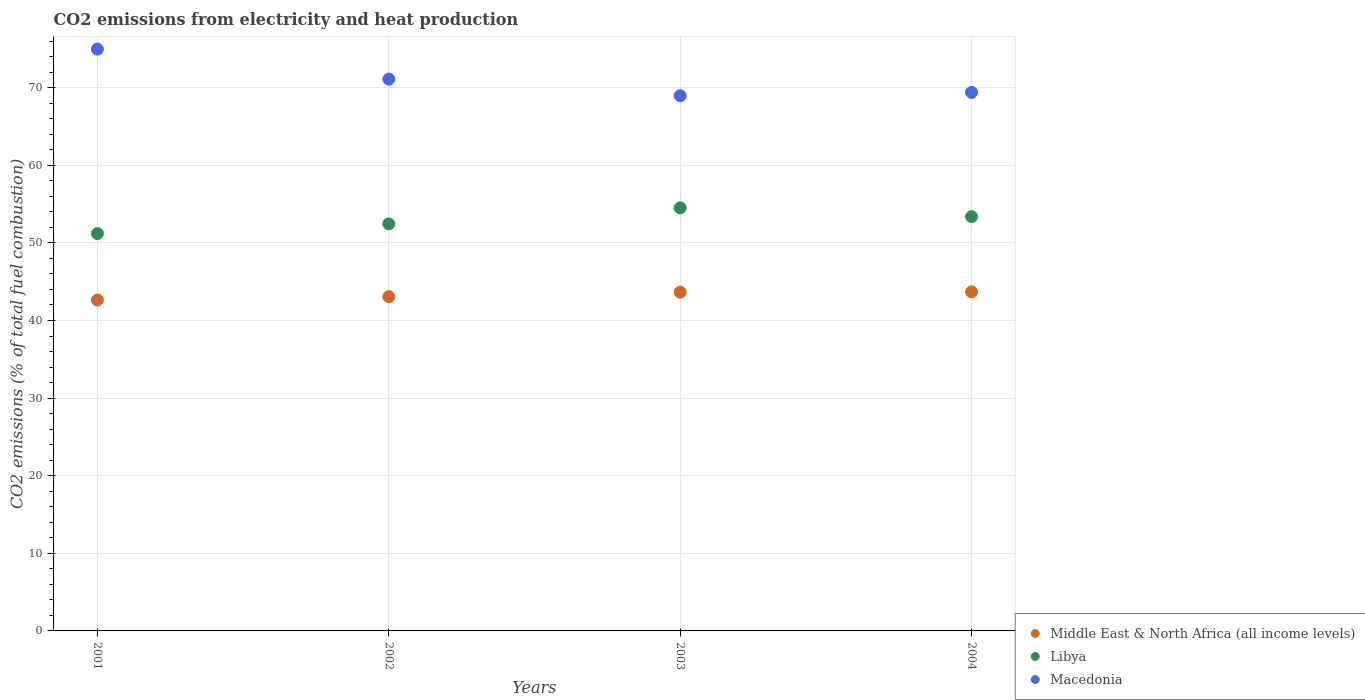How many different coloured dotlines are there?
Your response must be concise. 3. What is the amount of CO2 emitted in Macedonia in 2002?
Provide a succinct answer. 71.11. Across all years, what is the maximum amount of CO2 emitted in Libya?
Keep it short and to the point. 54.52. Across all years, what is the minimum amount of CO2 emitted in Libya?
Provide a short and direct response. 51.21. In which year was the amount of CO2 emitted in Middle East & North Africa (all income levels) minimum?
Provide a succinct answer. 2001. What is the total amount of CO2 emitted in Macedonia in the graph?
Keep it short and to the point. 284.44. What is the difference between the amount of CO2 emitted in Libya in 2003 and that in 2004?
Provide a short and direct response. 1.13. What is the difference between the amount of CO2 emitted in Middle East & North Africa (all income levels) in 2002 and the amount of CO2 emitted in Libya in 2003?
Your answer should be compact. -11.44. What is the average amount of CO2 emitted in Middle East & North Africa (all income levels) per year?
Give a very brief answer. 43.26. In the year 2002, what is the difference between the amount of CO2 emitted in Macedonia and amount of CO2 emitted in Libya?
Give a very brief answer. 18.66. In how many years, is the amount of CO2 emitted in Libya greater than 20 %?
Provide a succinct answer. 4. What is the ratio of the amount of CO2 emitted in Macedonia in 2002 to that in 2004?
Keep it short and to the point. 1.02. Is the amount of CO2 emitted in Macedonia in 2001 less than that in 2003?
Offer a very short reply. No. Is the difference between the amount of CO2 emitted in Macedonia in 2001 and 2003 greater than the difference between the amount of CO2 emitted in Libya in 2001 and 2003?
Give a very brief answer. Yes. What is the difference between the highest and the second highest amount of CO2 emitted in Libya?
Give a very brief answer. 1.13. What is the difference between the highest and the lowest amount of CO2 emitted in Libya?
Make the answer very short. 3.31. In how many years, is the amount of CO2 emitted in Libya greater than the average amount of CO2 emitted in Libya taken over all years?
Your answer should be very brief. 2. Does the amount of CO2 emitted in Libya monotonically increase over the years?
Provide a succinct answer. No. Is the amount of CO2 emitted in Libya strictly greater than the amount of CO2 emitted in Middle East & North Africa (all income levels) over the years?
Your answer should be very brief. Yes. Is the amount of CO2 emitted in Libya strictly less than the amount of CO2 emitted in Macedonia over the years?
Your answer should be compact. Yes. How many years are there in the graph?
Provide a short and direct response. 4. Does the graph contain any zero values?
Your response must be concise. No. How many legend labels are there?
Your answer should be very brief. 3. What is the title of the graph?
Offer a very short reply. CO2 emissions from electricity and heat production. Does "Virgin Islands" appear as one of the legend labels in the graph?
Your answer should be very brief. No. What is the label or title of the Y-axis?
Provide a short and direct response. CO2 emissions (% of total fuel combustion). What is the CO2 emissions (% of total fuel combustion) of Middle East & North Africa (all income levels) in 2001?
Keep it short and to the point. 42.64. What is the CO2 emissions (% of total fuel combustion) of Libya in 2001?
Your answer should be compact. 51.21. What is the CO2 emissions (% of total fuel combustion) in Macedonia in 2001?
Provide a short and direct response. 74.97. What is the CO2 emissions (% of total fuel combustion) in Middle East & North Africa (all income levels) in 2002?
Provide a short and direct response. 43.07. What is the CO2 emissions (% of total fuel combustion) in Libya in 2002?
Make the answer very short. 52.45. What is the CO2 emissions (% of total fuel combustion) of Macedonia in 2002?
Ensure brevity in your answer.  71.11. What is the CO2 emissions (% of total fuel combustion) of Middle East & North Africa (all income levels) in 2003?
Your answer should be compact. 43.65. What is the CO2 emissions (% of total fuel combustion) of Libya in 2003?
Your answer should be compact. 54.52. What is the CO2 emissions (% of total fuel combustion) of Macedonia in 2003?
Keep it short and to the point. 68.97. What is the CO2 emissions (% of total fuel combustion) in Middle East & North Africa (all income levels) in 2004?
Offer a terse response. 43.69. What is the CO2 emissions (% of total fuel combustion) in Libya in 2004?
Give a very brief answer. 53.38. What is the CO2 emissions (% of total fuel combustion) of Macedonia in 2004?
Make the answer very short. 69.4. Across all years, what is the maximum CO2 emissions (% of total fuel combustion) of Middle East & North Africa (all income levels)?
Your answer should be very brief. 43.69. Across all years, what is the maximum CO2 emissions (% of total fuel combustion) of Libya?
Provide a succinct answer. 54.52. Across all years, what is the maximum CO2 emissions (% of total fuel combustion) in Macedonia?
Offer a terse response. 74.97. Across all years, what is the minimum CO2 emissions (% of total fuel combustion) in Middle East & North Africa (all income levels)?
Your answer should be very brief. 42.64. Across all years, what is the minimum CO2 emissions (% of total fuel combustion) in Libya?
Make the answer very short. 51.21. Across all years, what is the minimum CO2 emissions (% of total fuel combustion) of Macedonia?
Offer a very short reply. 68.97. What is the total CO2 emissions (% of total fuel combustion) in Middle East & North Africa (all income levels) in the graph?
Provide a succinct answer. 173.05. What is the total CO2 emissions (% of total fuel combustion) of Libya in the graph?
Your response must be concise. 211.56. What is the total CO2 emissions (% of total fuel combustion) of Macedonia in the graph?
Offer a very short reply. 284.44. What is the difference between the CO2 emissions (% of total fuel combustion) in Middle East & North Africa (all income levels) in 2001 and that in 2002?
Provide a succinct answer. -0.44. What is the difference between the CO2 emissions (% of total fuel combustion) in Libya in 2001 and that in 2002?
Provide a succinct answer. -1.24. What is the difference between the CO2 emissions (% of total fuel combustion) in Macedonia in 2001 and that in 2002?
Offer a very short reply. 3.86. What is the difference between the CO2 emissions (% of total fuel combustion) of Middle East & North Africa (all income levels) in 2001 and that in 2003?
Your response must be concise. -1.01. What is the difference between the CO2 emissions (% of total fuel combustion) of Libya in 2001 and that in 2003?
Your response must be concise. -3.31. What is the difference between the CO2 emissions (% of total fuel combustion) of Macedonia in 2001 and that in 2003?
Your response must be concise. 6.01. What is the difference between the CO2 emissions (% of total fuel combustion) in Middle East & North Africa (all income levels) in 2001 and that in 2004?
Your response must be concise. -1.05. What is the difference between the CO2 emissions (% of total fuel combustion) of Libya in 2001 and that in 2004?
Your answer should be very brief. -2.18. What is the difference between the CO2 emissions (% of total fuel combustion) in Macedonia in 2001 and that in 2004?
Keep it short and to the point. 5.58. What is the difference between the CO2 emissions (% of total fuel combustion) of Middle East & North Africa (all income levels) in 2002 and that in 2003?
Your answer should be compact. -0.57. What is the difference between the CO2 emissions (% of total fuel combustion) of Libya in 2002 and that in 2003?
Give a very brief answer. -2.07. What is the difference between the CO2 emissions (% of total fuel combustion) in Macedonia in 2002 and that in 2003?
Your answer should be very brief. 2.14. What is the difference between the CO2 emissions (% of total fuel combustion) in Middle East & North Africa (all income levels) in 2002 and that in 2004?
Provide a short and direct response. -0.62. What is the difference between the CO2 emissions (% of total fuel combustion) of Libya in 2002 and that in 2004?
Give a very brief answer. -0.93. What is the difference between the CO2 emissions (% of total fuel combustion) of Macedonia in 2002 and that in 2004?
Your response must be concise. 1.71. What is the difference between the CO2 emissions (% of total fuel combustion) of Middle East & North Africa (all income levels) in 2003 and that in 2004?
Offer a very short reply. -0.05. What is the difference between the CO2 emissions (% of total fuel combustion) in Libya in 2003 and that in 2004?
Offer a terse response. 1.13. What is the difference between the CO2 emissions (% of total fuel combustion) in Macedonia in 2003 and that in 2004?
Your answer should be compact. -0.43. What is the difference between the CO2 emissions (% of total fuel combustion) in Middle East & North Africa (all income levels) in 2001 and the CO2 emissions (% of total fuel combustion) in Libya in 2002?
Keep it short and to the point. -9.81. What is the difference between the CO2 emissions (% of total fuel combustion) in Middle East & North Africa (all income levels) in 2001 and the CO2 emissions (% of total fuel combustion) in Macedonia in 2002?
Provide a short and direct response. -28.47. What is the difference between the CO2 emissions (% of total fuel combustion) in Libya in 2001 and the CO2 emissions (% of total fuel combustion) in Macedonia in 2002?
Your answer should be compact. -19.9. What is the difference between the CO2 emissions (% of total fuel combustion) of Middle East & North Africa (all income levels) in 2001 and the CO2 emissions (% of total fuel combustion) of Libya in 2003?
Offer a very short reply. -11.88. What is the difference between the CO2 emissions (% of total fuel combustion) of Middle East & North Africa (all income levels) in 2001 and the CO2 emissions (% of total fuel combustion) of Macedonia in 2003?
Provide a short and direct response. -26.33. What is the difference between the CO2 emissions (% of total fuel combustion) in Libya in 2001 and the CO2 emissions (% of total fuel combustion) in Macedonia in 2003?
Provide a short and direct response. -17.76. What is the difference between the CO2 emissions (% of total fuel combustion) of Middle East & North Africa (all income levels) in 2001 and the CO2 emissions (% of total fuel combustion) of Libya in 2004?
Make the answer very short. -10.75. What is the difference between the CO2 emissions (% of total fuel combustion) of Middle East & North Africa (all income levels) in 2001 and the CO2 emissions (% of total fuel combustion) of Macedonia in 2004?
Give a very brief answer. -26.76. What is the difference between the CO2 emissions (% of total fuel combustion) in Libya in 2001 and the CO2 emissions (% of total fuel combustion) in Macedonia in 2004?
Provide a succinct answer. -18.19. What is the difference between the CO2 emissions (% of total fuel combustion) of Middle East & North Africa (all income levels) in 2002 and the CO2 emissions (% of total fuel combustion) of Libya in 2003?
Keep it short and to the point. -11.44. What is the difference between the CO2 emissions (% of total fuel combustion) of Middle East & North Africa (all income levels) in 2002 and the CO2 emissions (% of total fuel combustion) of Macedonia in 2003?
Keep it short and to the point. -25.89. What is the difference between the CO2 emissions (% of total fuel combustion) in Libya in 2002 and the CO2 emissions (% of total fuel combustion) in Macedonia in 2003?
Your answer should be compact. -16.52. What is the difference between the CO2 emissions (% of total fuel combustion) in Middle East & North Africa (all income levels) in 2002 and the CO2 emissions (% of total fuel combustion) in Libya in 2004?
Ensure brevity in your answer.  -10.31. What is the difference between the CO2 emissions (% of total fuel combustion) of Middle East & North Africa (all income levels) in 2002 and the CO2 emissions (% of total fuel combustion) of Macedonia in 2004?
Offer a terse response. -26.32. What is the difference between the CO2 emissions (% of total fuel combustion) of Libya in 2002 and the CO2 emissions (% of total fuel combustion) of Macedonia in 2004?
Ensure brevity in your answer.  -16.95. What is the difference between the CO2 emissions (% of total fuel combustion) of Middle East & North Africa (all income levels) in 2003 and the CO2 emissions (% of total fuel combustion) of Libya in 2004?
Provide a short and direct response. -9.74. What is the difference between the CO2 emissions (% of total fuel combustion) in Middle East & North Africa (all income levels) in 2003 and the CO2 emissions (% of total fuel combustion) in Macedonia in 2004?
Your response must be concise. -25.75. What is the difference between the CO2 emissions (% of total fuel combustion) in Libya in 2003 and the CO2 emissions (% of total fuel combustion) in Macedonia in 2004?
Ensure brevity in your answer.  -14.88. What is the average CO2 emissions (% of total fuel combustion) in Middle East & North Africa (all income levels) per year?
Offer a very short reply. 43.26. What is the average CO2 emissions (% of total fuel combustion) in Libya per year?
Ensure brevity in your answer.  52.89. What is the average CO2 emissions (% of total fuel combustion) in Macedonia per year?
Your answer should be very brief. 71.11. In the year 2001, what is the difference between the CO2 emissions (% of total fuel combustion) of Middle East & North Africa (all income levels) and CO2 emissions (% of total fuel combustion) of Libya?
Provide a succinct answer. -8.57. In the year 2001, what is the difference between the CO2 emissions (% of total fuel combustion) of Middle East & North Africa (all income levels) and CO2 emissions (% of total fuel combustion) of Macedonia?
Provide a succinct answer. -32.33. In the year 2001, what is the difference between the CO2 emissions (% of total fuel combustion) in Libya and CO2 emissions (% of total fuel combustion) in Macedonia?
Your answer should be very brief. -23.76. In the year 2002, what is the difference between the CO2 emissions (% of total fuel combustion) in Middle East & North Africa (all income levels) and CO2 emissions (% of total fuel combustion) in Libya?
Provide a short and direct response. -9.38. In the year 2002, what is the difference between the CO2 emissions (% of total fuel combustion) in Middle East & North Africa (all income levels) and CO2 emissions (% of total fuel combustion) in Macedonia?
Provide a short and direct response. -28.03. In the year 2002, what is the difference between the CO2 emissions (% of total fuel combustion) of Libya and CO2 emissions (% of total fuel combustion) of Macedonia?
Keep it short and to the point. -18.66. In the year 2003, what is the difference between the CO2 emissions (% of total fuel combustion) in Middle East & North Africa (all income levels) and CO2 emissions (% of total fuel combustion) in Libya?
Your answer should be very brief. -10.87. In the year 2003, what is the difference between the CO2 emissions (% of total fuel combustion) of Middle East & North Africa (all income levels) and CO2 emissions (% of total fuel combustion) of Macedonia?
Provide a succinct answer. -25.32. In the year 2003, what is the difference between the CO2 emissions (% of total fuel combustion) in Libya and CO2 emissions (% of total fuel combustion) in Macedonia?
Your answer should be compact. -14.45. In the year 2004, what is the difference between the CO2 emissions (% of total fuel combustion) of Middle East & North Africa (all income levels) and CO2 emissions (% of total fuel combustion) of Libya?
Keep it short and to the point. -9.69. In the year 2004, what is the difference between the CO2 emissions (% of total fuel combustion) of Middle East & North Africa (all income levels) and CO2 emissions (% of total fuel combustion) of Macedonia?
Offer a very short reply. -25.7. In the year 2004, what is the difference between the CO2 emissions (% of total fuel combustion) in Libya and CO2 emissions (% of total fuel combustion) in Macedonia?
Offer a very short reply. -16.01. What is the ratio of the CO2 emissions (% of total fuel combustion) of Libya in 2001 to that in 2002?
Make the answer very short. 0.98. What is the ratio of the CO2 emissions (% of total fuel combustion) in Macedonia in 2001 to that in 2002?
Make the answer very short. 1.05. What is the ratio of the CO2 emissions (% of total fuel combustion) of Middle East & North Africa (all income levels) in 2001 to that in 2003?
Your answer should be compact. 0.98. What is the ratio of the CO2 emissions (% of total fuel combustion) of Libya in 2001 to that in 2003?
Make the answer very short. 0.94. What is the ratio of the CO2 emissions (% of total fuel combustion) of Macedonia in 2001 to that in 2003?
Your response must be concise. 1.09. What is the ratio of the CO2 emissions (% of total fuel combustion) in Middle East & North Africa (all income levels) in 2001 to that in 2004?
Your response must be concise. 0.98. What is the ratio of the CO2 emissions (% of total fuel combustion) of Libya in 2001 to that in 2004?
Make the answer very short. 0.96. What is the ratio of the CO2 emissions (% of total fuel combustion) of Macedonia in 2001 to that in 2004?
Ensure brevity in your answer.  1.08. What is the ratio of the CO2 emissions (% of total fuel combustion) in Middle East & North Africa (all income levels) in 2002 to that in 2003?
Offer a terse response. 0.99. What is the ratio of the CO2 emissions (% of total fuel combustion) in Libya in 2002 to that in 2003?
Your answer should be compact. 0.96. What is the ratio of the CO2 emissions (% of total fuel combustion) in Macedonia in 2002 to that in 2003?
Your answer should be very brief. 1.03. What is the ratio of the CO2 emissions (% of total fuel combustion) of Middle East & North Africa (all income levels) in 2002 to that in 2004?
Offer a terse response. 0.99. What is the ratio of the CO2 emissions (% of total fuel combustion) of Libya in 2002 to that in 2004?
Provide a succinct answer. 0.98. What is the ratio of the CO2 emissions (% of total fuel combustion) in Macedonia in 2002 to that in 2004?
Give a very brief answer. 1.02. What is the ratio of the CO2 emissions (% of total fuel combustion) in Middle East & North Africa (all income levels) in 2003 to that in 2004?
Your answer should be very brief. 1. What is the ratio of the CO2 emissions (% of total fuel combustion) of Libya in 2003 to that in 2004?
Make the answer very short. 1.02. What is the difference between the highest and the second highest CO2 emissions (% of total fuel combustion) of Middle East & North Africa (all income levels)?
Give a very brief answer. 0.05. What is the difference between the highest and the second highest CO2 emissions (% of total fuel combustion) in Libya?
Give a very brief answer. 1.13. What is the difference between the highest and the second highest CO2 emissions (% of total fuel combustion) in Macedonia?
Provide a succinct answer. 3.86. What is the difference between the highest and the lowest CO2 emissions (% of total fuel combustion) of Middle East & North Africa (all income levels)?
Offer a terse response. 1.05. What is the difference between the highest and the lowest CO2 emissions (% of total fuel combustion) of Libya?
Provide a short and direct response. 3.31. What is the difference between the highest and the lowest CO2 emissions (% of total fuel combustion) in Macedonia?
Your answer should be very brief. 6.01. 